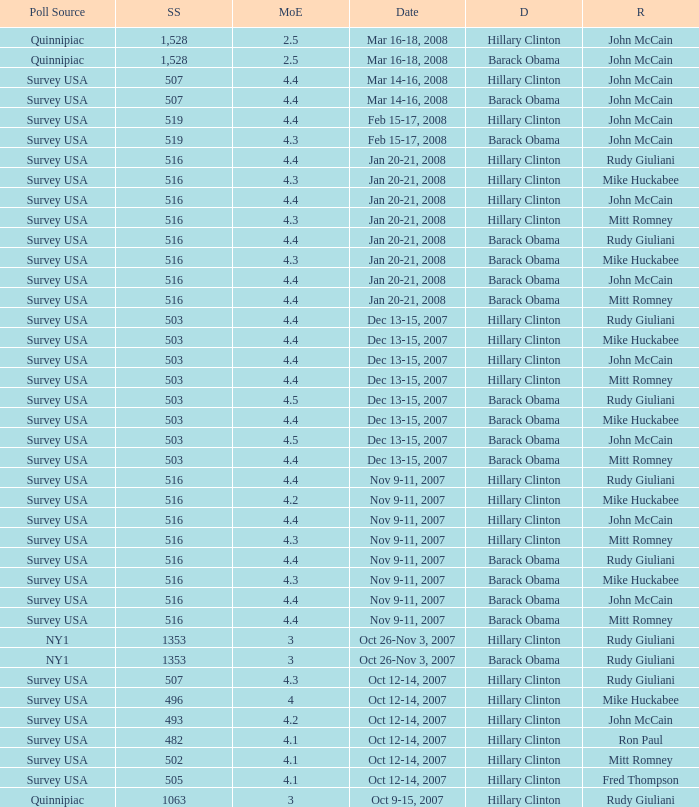What was the date of the poll with a sample size of 496 where Republican Mike Huckabee was chosen? Oct 12-14, 2007. 